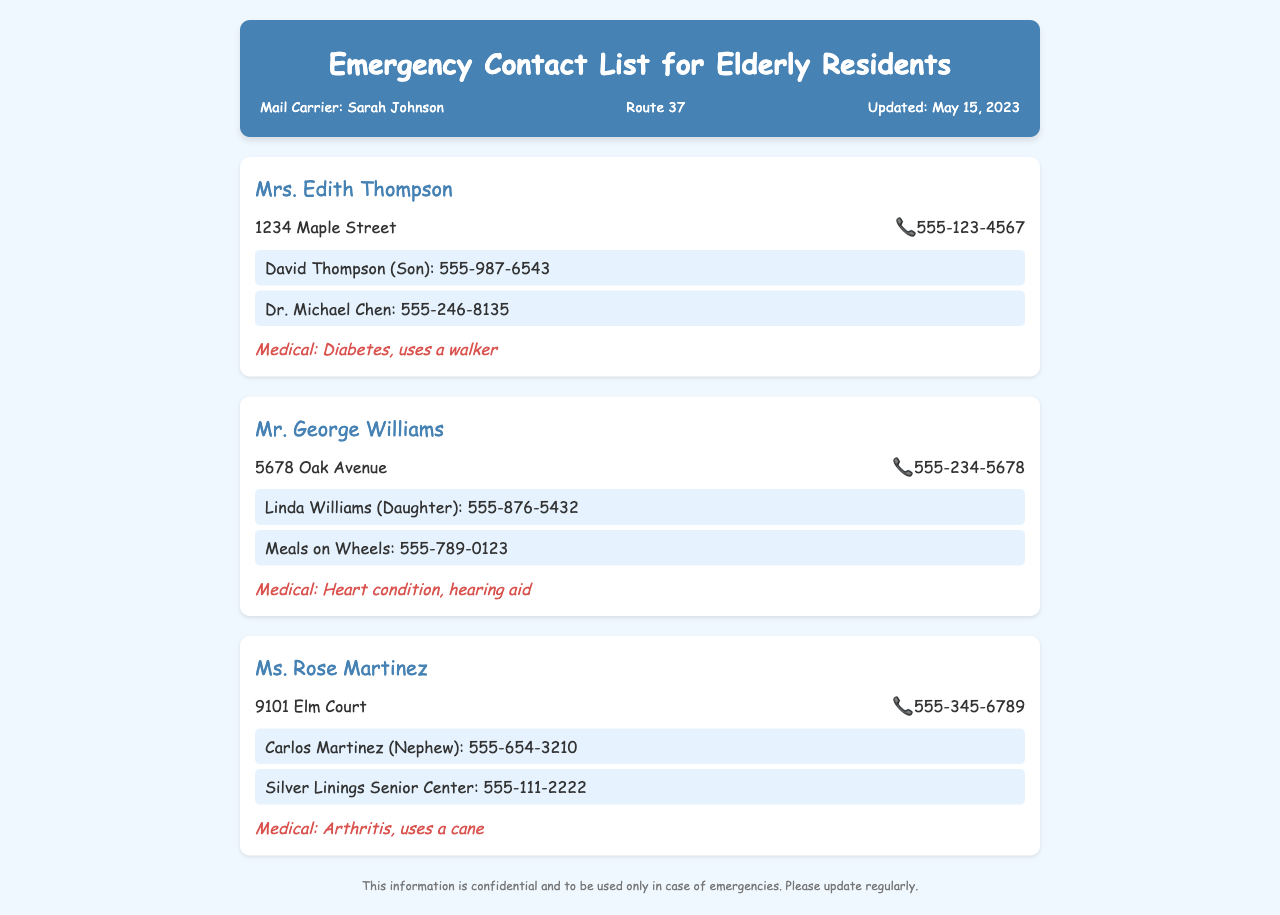What is Mrs. Edith Thompson's address? The address for Mrs. Edith Thompson is listed in the contact details section of her card.
Answer: 1234 Maple Street Who is Mr. George Williams' emergency contact? The emergency contact listed for Mr. George Williams is his daughter Linda Williams.
Answer: Linda Williams (Daughter) What medical condition does Ms. Rose Martinez have? The medical information for Ms. Rose Martinez is provided in the medical info section of her card.
Answer: Arthritis What is the phone number for Dr. Michael Chen? The phone number for Dr. Michael Chen is included in the emergency contacts section for Mrs. Edith Thompson.
Answer: 555-246-8135 How many emergency contacts does Mr. George Williams have? The document lists the number of emergency contacts under Mr. George Williams' information.
Answer: 2 Who is the mail carrier for this document? The mail carrier's name is mentioned at the top of the document, along with her route information.
Answer: Sarah Johnson When was the document last updated? The date of the last update is provided in the header section of the document.
Answer: May 15, 2023 What does the medical info section for Mrs. Edith Thompson specify? The medical info section contains specific medical conditions and assistance details for Mrs. Edith Thompson.
Answer: Diabetes, uses a walker 